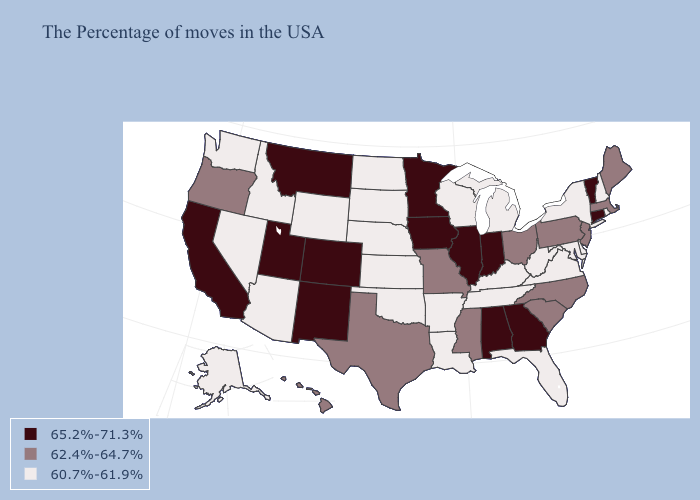Which states have the lowest value in the South?
Quick response, please. Delaware, Maryland, Virginia, West Virginia, Florida, Kentucky, Tennessee, Louisiana, Arkansas, Oklahoma. What is the value of Kansas?
Answer briefly. 60.7%-61.9%. Name the states that have a value in the range 62.4%-64.7%?
Be succinct. Maine, Massachusetts, New Jersey, Pennsylvania, North Carolina, South Carolina, Ohio, Mississippi, Missouri, Texas, Oregon, Hawaii. What is the value of Indiana?
Concise answer only. 65.2%-71.3%. What is the highest value in states that border West Virginia?
Keep it brief. 62.4%-64.7%. Is the legend a continuous bar?
Answer briefly. No. Among the states that border Florida , which have the lowest value?
Answer briefly. Georgia, Alabama. Name the states that have a value in the range 60.7%-61.9%?
Write a very short answer. Rhode Island, New Hampshire, New York, Delaware, Maryland, Virginia, West Virginia, Florida, Michigan, Kentucky, Tennessee, Wisconsin, Louisiana, Arkansas, Kansas, Nebraska, Oklahoma, South Dakota, North Dakota, Wyoming, Arizona, Idaho, Nevada, Washington, Alaska. What is the value of North Carolina?
Keep it brief. 62.4%-64.7%. Is the legend a continuous bar?
Be succinct. No. What is the lowest value in the South?
Quick response, please. 60.7%-61.9%. Does Rhode Island have the lowest value in the Northeast?
Short answer required. Yes. Which states have the lowest value in the USA?
Be succinct. Rhode Island, New Hampshire, New York, Delaware, Maryland, Virginia, West Virginia, Florida, Michigan, Kentucky, Tennessee, Wisconsin, Louisiana, Arkansas, Kansas, Nebraska, Oklahoma, South Dakota, North Dakota, Wyoming, Arizona, Idaho, Nevada, Washington, Alaska. Name the states that have a value in the range 60.7%-61.9%?
Write a very short answer. Rhode Island, New Hampshire, New York, Delaware, Maryland, Virginia, West Virginia, Florida, Michigan, Kentucky, Tennessee, Wisconsin, Louisiana, Arkansas, Kansas, Nebraska, Oklahoma, South Dakota, North Dakota, Wyoming, Arizona, Idaho, Nevada, Washington, Alaska. Which states have the lowest value in the USA?
Short answer required. Rhode Island, New Hampshire, New York, Delaware, Maryland, Virginia, West Virginia, Florida, Michigan, Kentucky, Tennessee, Wisconsin, Louisiana, Arkansas, Kansas, Nebraska, Oklahoma, South Dakota, North Dakota, Wyoming, Arizona, Idaho, Nevada, Washington, Alaska. 